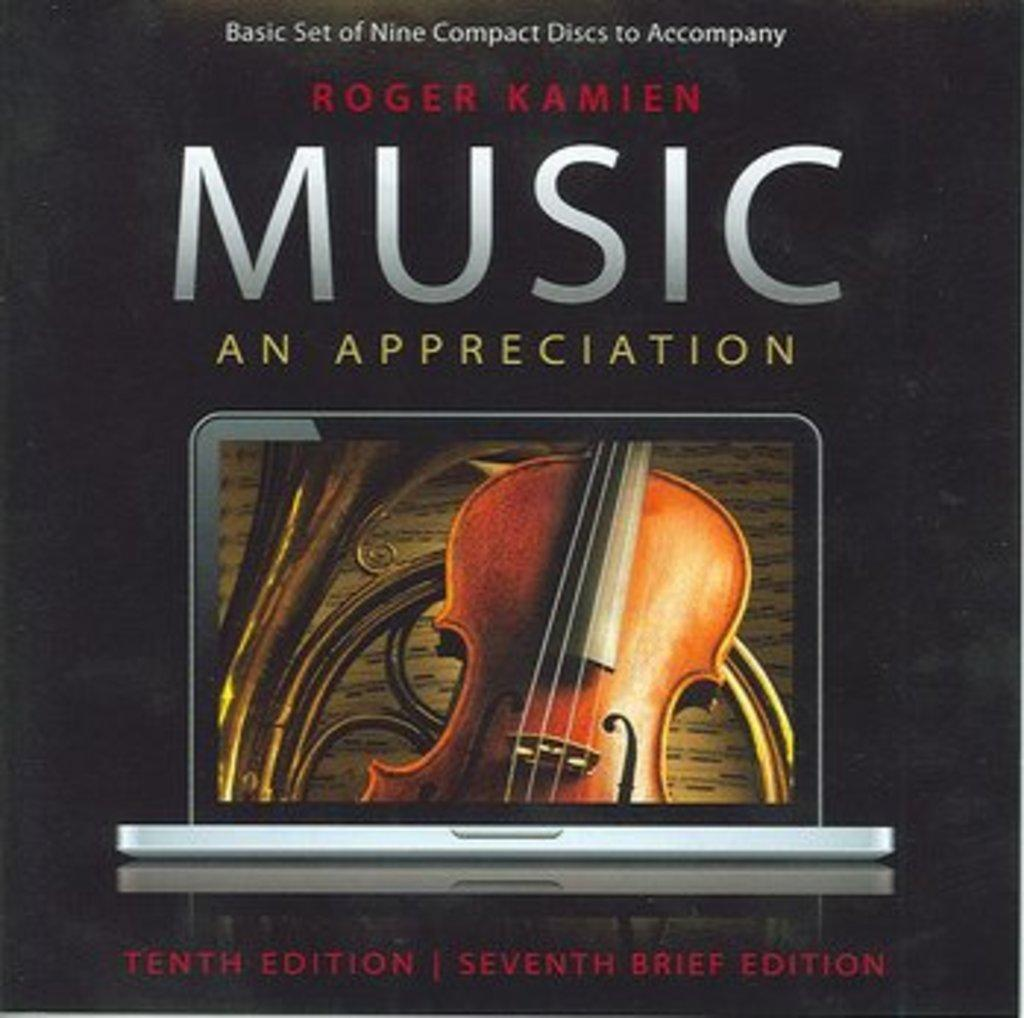<image>
Summarize the visual content of the image. The cover to Roger Kamien's "Music: An Appreciation" compact disc features a violin displayed on a laptop screen. 